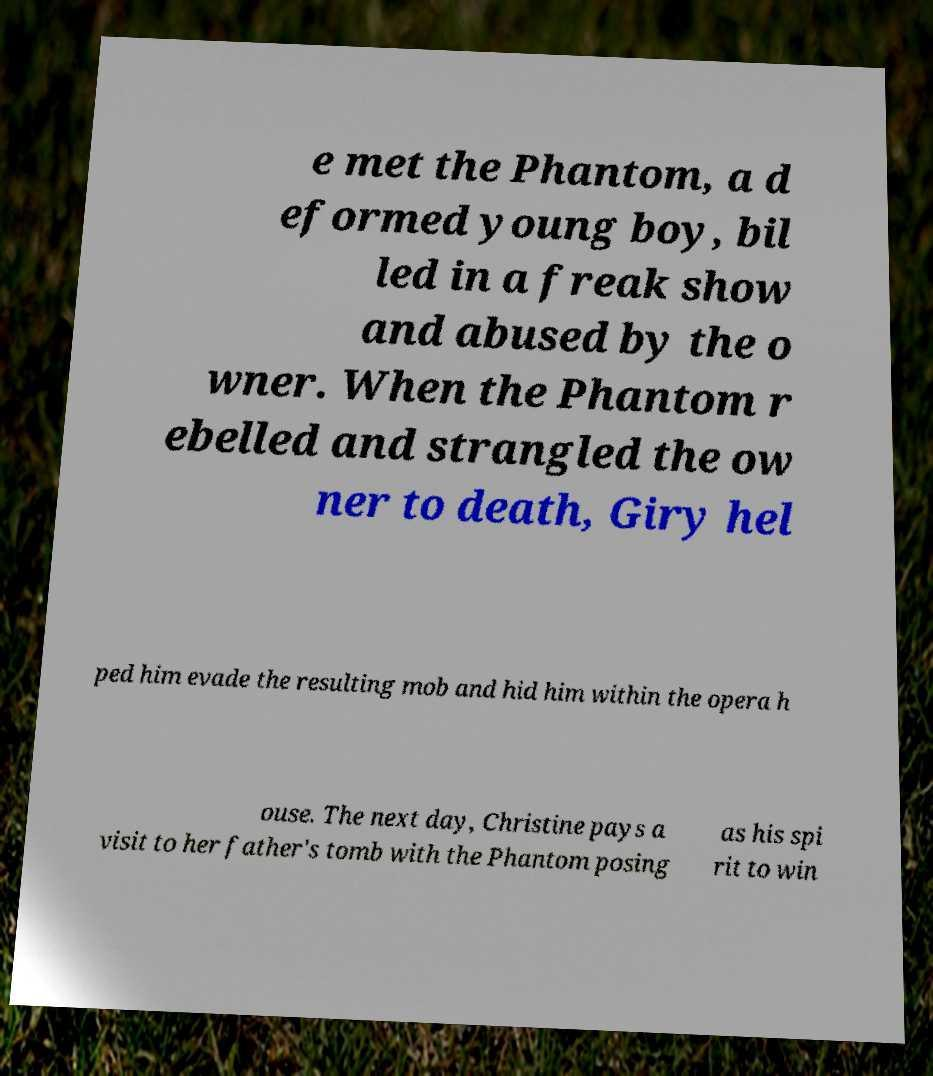Please identify and transcribe the text found in this image. e met the Phantom, a d eformed young boy, bil led in a freak show and abused by the o wner. When the Phantom r ebelled and strangled the ow ner to death, Giry hel ped him evade the resulting mob and hid him within the opera h ouse. The next day, Christine pays a visit to her father's tomb with the Phantom posing as his spi rit to win 